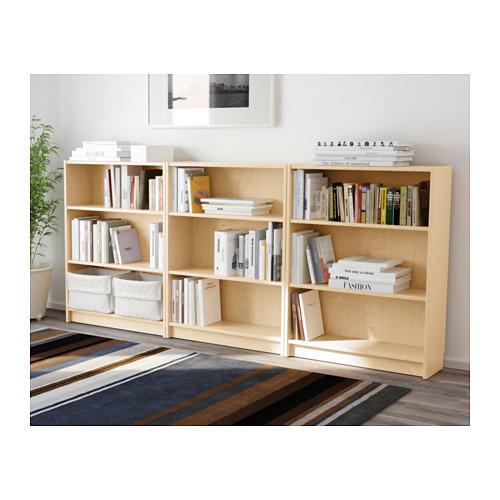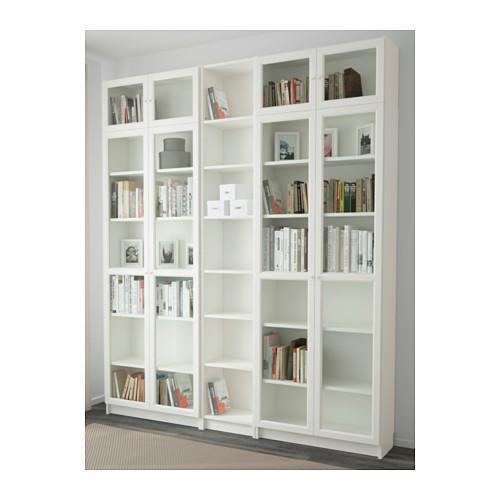The first image is the image on the left, the second image is the image on the right. Evaluate the accuracy of this statement regarding the images: "One of the shelves is six rows tall.". Is it true? Answer yes or no. No. The first image is the image on the left, the second image is the image on the right. Assess this claim about the two images: "A potted plant stands to the left of a bookshelf in each image.". Correct or not? Answer yes or no. No. 